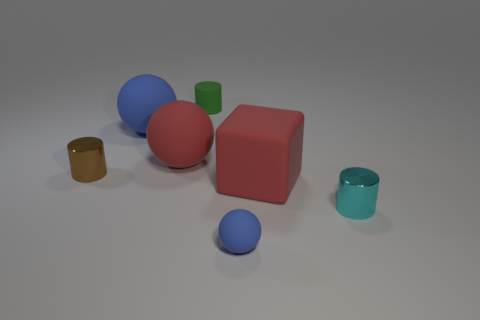Add 2 red balls. How many objects exist? 9 Subtract all spheres. How many objects are left? 4 Subtract all large yellow shiny objects. Subtract all blue balls. How many objects are left? 5 Add 7 brown metal cylinders. How many brown metal cylinders are left? 8 Add 1 red matte spheres. How many red matte spheres exist? 2 Subtract 1 red cubes. How many objects are left? 6 